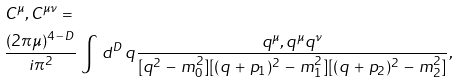Convert formula to latex. <formula><loc_0><loc_0><loc_500><loc_500>& C ^ { \mu } , C ^ { \mu \nu } = \\ & \frac { ( 2 \pi \mu ) ^ { 4 \, - \, D } } { i \pi ^ { 2 } } \, \int \, d ^ { D } \, q \frac { q ^ { \mu } , q ^ { \mu } q ^ { \nu } } { [ q ^ { 2 } \, - \, m _ { 0 } ^ { 2 } ] [ ( q \, + \, p _ { 1 } ) ^ { 2 } \, - \, m _ { 1 } ^ { 2 } ] [ ( q \, + \, p _ { 2 } ) ^ { 2 } \, - \, m _ { 2 } ^ { 2 } ] } ,</formula> 